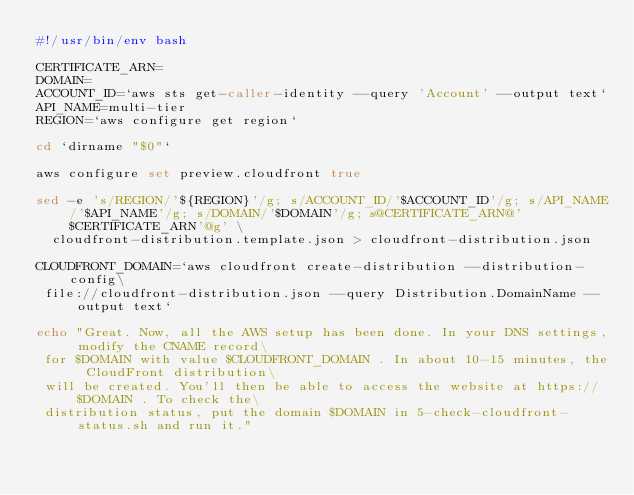Convert code to text. <code><loc_0><loc_0><loc_500><loc_500><_Bash_>#!/usr/bin/env bash

CERTIFICATE_ARN=
DOMAIN=
ACCOUNT_ID=`aws sts get-caller-identity --query 'Account' --output text`
API_NAME=multi-tier
REGION=`aws configure get region`

cd `dirname "$0"`

aws configure set preview.cloudfront true

sed -e 's/REGION/'${REGION}'/g; s/ACCOUNT_ID/'$ACCOUNT_ID'/g; s/API_NAME/'$API_NAME'/g; s/DOMAIN/'$DOMAIN'/g; s@CERTIFICATE_ARN@'$CERTIFICATE_ARN'@g' \
  cloudfront-distribution.template.json > cloudfront-distribution.json

CLOUDFRONT_DOMAIN=`aws cloudfront create-distribution --distribution-config\
 file://cloudfront-distribution.json --query Distribution.DomainName --output text`

echo "Great. Now, all the AWS setup has been done. In your DNS settings, modify the CNAME record\
 for $DOMAIN with value $CLOUDFRONT_DOMAIN . In about 10-15 minutes, the CloudFront distribution\
 will be created. You'll then be able to access the website at https://$DOMAIN . To check the\
 distribution status, put the domain $DOMAIN in 5-check-cloudfront-status.sh and run it."
</code> 